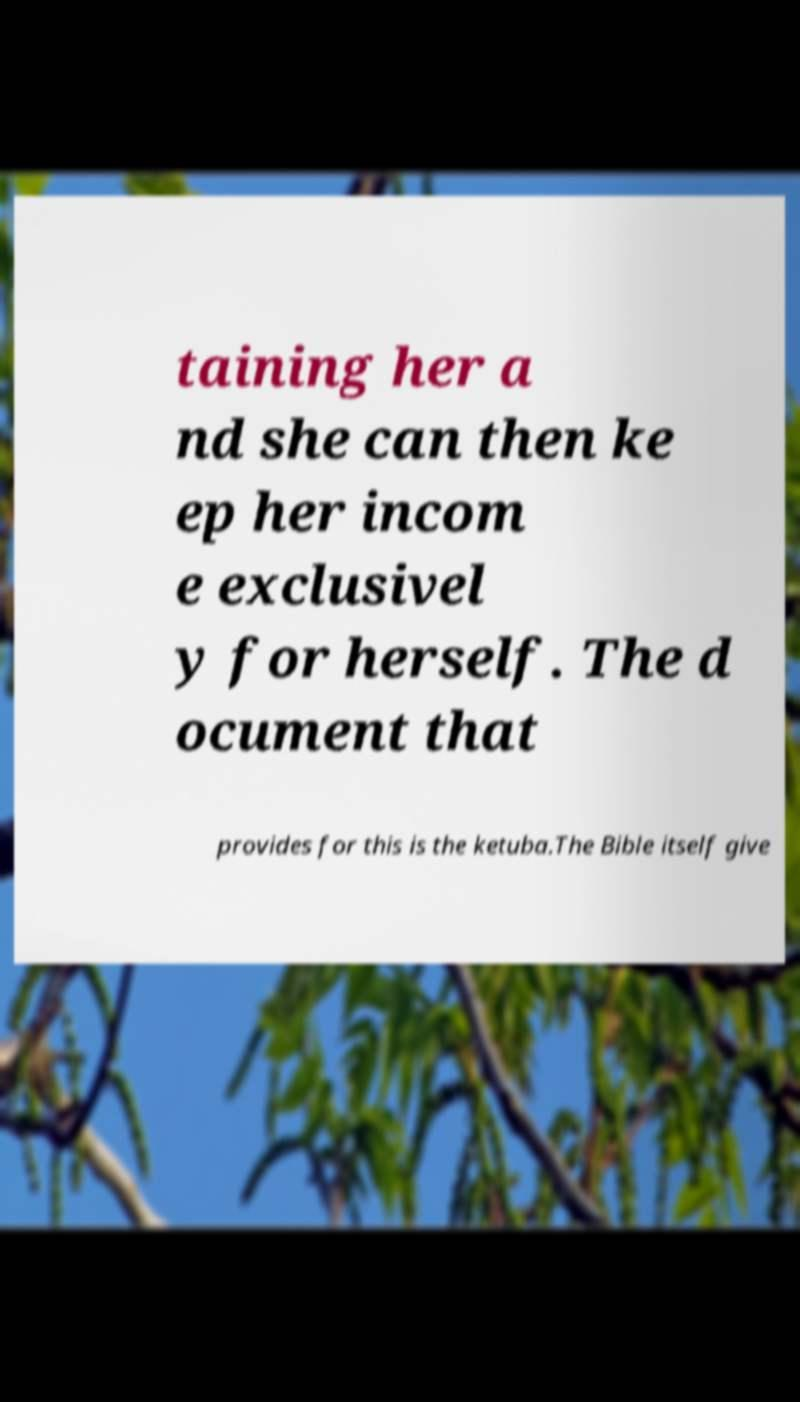I need the written content from this picture converted into text. Can you do that? taining her a nd she can then ke ep her incom e exclusivel y for herself. The d ocument that provides for this is the ketuba.The Bible itself give 